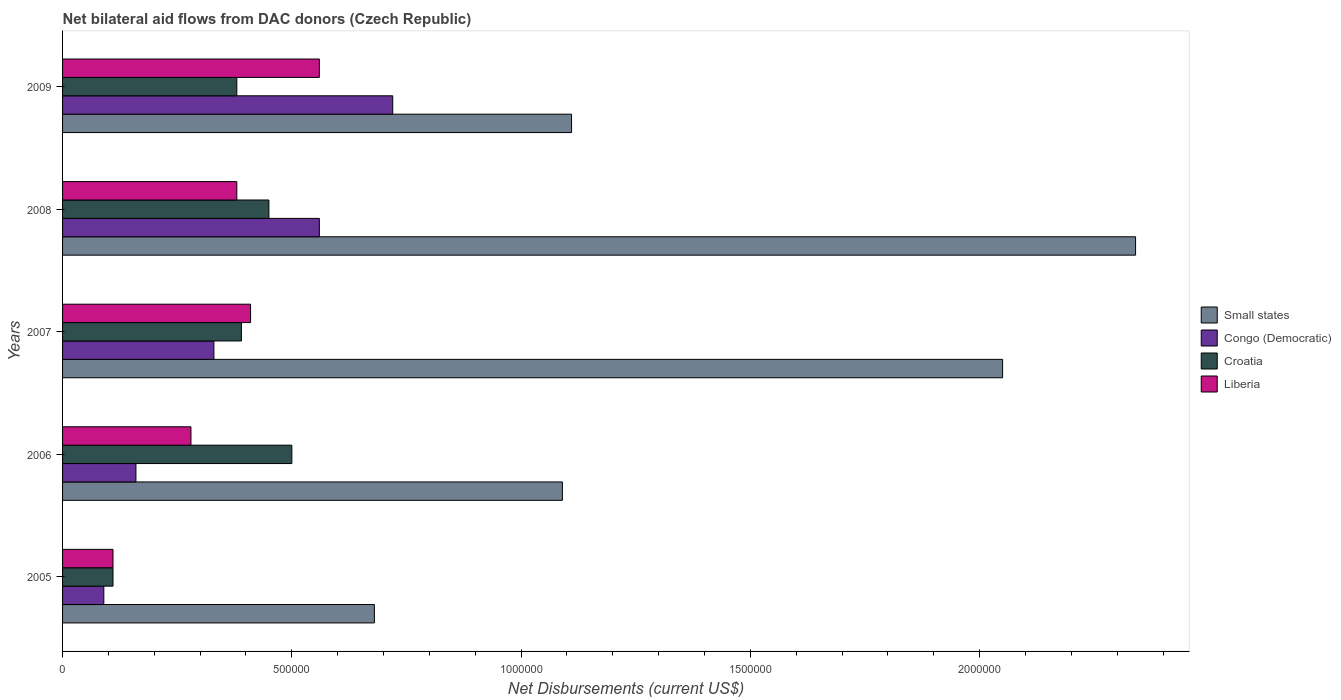How many different coloured bars are there?
Make the answer very short. 4. Are the number of bars per tick equal to the number of legend labels?
Your answer should be very brief. Yes. In how many cases, is the number of bars for a given year not equal to the number of legend labels?
Give a very brief answer. 0. What is the net bilateral aid flows in Small states in 2009?
Your response must be concise. 1.11e+06. Across all years, what is the maximum net bilateral aid flows in Small states?
Keep it short and to the point. 2.34e+06. In which year was the net bilateral aid flows in Small states maximum?
Your answer should be compact. 2008. In which year was the net bilateral aid flows in Congo (Democratic) minimum?
Provide a succinct answer. 2005. What is the total net bilateral aid flows in Croatia in the graph?
Offer a terse response. 1.83e+06. What is the difference between the net bilateral aid flows in Croatia in 2008 and that in 2009?
Make the answer very short. 7.00e+04. What is the difference between the net bilateral aid flows in Croatia in 2009 and the net bilateral aid flows in Congo (Democratic) in 2007?
Your response must be concise. 5.00e+04. What is the average net bilateral aid flows in Congo (Democratic) per year?
Provide a succinct answer. 3.72e+05. In the year 2009, what is the difference between the net bilateral aid flows in Small states and net bilateral aid flows in Congo (Democratic)?
Make the answer very short. 3.90e+05. What is the ratio of the net bilateral aid flows in Small states in 2005 to that in 2006?
Keep it short and to the point. 0.62. Is the net bilateral aid flows in Congo (Democratic) in 2005 less than that in 2006?
Provide a succinct answer. Yes. Is the difference between the net bilateral aid flows in Small states in 2008 and 2009 greater than the difference between the net bilateral aid flows in Congo (Democratic) in 2008 and 2009?
Your answer should be very brief. Yes. What is the difference between the highest and the second highest net bilateral aid flows in Liberia?
Make the answer very short. 1.50e+05. What is the difference between the highest and the lowest net bilateral aid flows in Liberia?
Your response must be concise. 4.50e+05. In how many years, is the net bilateral aid flows in Croatia greater than the average net bilateral aid flows in Croatia taken over all years?
Give a very brief answer. 4. What does the 4th bar from the top in 2005 represents?
Provide a short and direct response. Small states. What does the 3rd bar from the bottom in 2009 represents?
Provide a succinct answer. Croatia. Is it the case that in every year, the sum of the net bilateral aid flows in Liberia and net bilateral aid flows in Congo (Democratic) is greater than the net bilateral aid flows in Croatia?
Keep it short and to the point. No. What is the difference between two consecutive major ticks on the X-axis?
Keep it short and to the point. 5.00e+05. Are the values on the major ticks of X-axis written in scientific E-notation?
Make the answer very short. No. Does the graph contain any zero values?
Your response must be concise. No. How many legend labels are there?
Ensure brevity in your answer.  4. How are the legend labels stacked?
Provide a short and direct response. Vertical. What is the title of the graph?
Give a very brief answer. Net bilateral aid flows from DAC donors (Czech Republic). Does "Swaziland" appear as one of the legend labels in the graph?
Your response must be concise. No. What is the label or title of the X-axis?
Give a very brief answer. Net Disbursements (current US$). What is the label or title of the Y-axis?
Make the answer very short. Years. What is the Net Disbursements (current US$) in Small states in 2005?
Provide a short and direct response. 6.80e+05. What is the Net Disbursements (current US$) in Congo (Democratic) in 2005?
Keep it short and to the point. 9.00e+04. What is the Net Disbursements (current US$) of Croatia in 2005?
Your response must be concise. 1.10e+05. What is the Net Disbursements (current US$) in Liberia in 2005?
Your response must be concise. 1.10e+05. What is the Net Disbursements (current US$) of Small states in 2006?
Make the answer very short. 1.09e+06. What is the Net Disbursements (current US$) in Liberia in 2006?
Offer a terse response. 2.80e+05. What is the Net Disbursements (current US$) of Small states in 2007?
Offer a very short reply. 2.05e+06. What is the Net Disbursements (current US$) of Small states in 2008?
Offer a very short reply. 2.34e+06. What is the Net Disbursements (current US$) in Congo (Democratic) in 2008?
Offer a terse response. 5.60e+05. What is the Net Disbursements (current US$) of Small states in 2009?
Make the answer very short. 1.11e+06. What is the Net Disbursements (current US$) in Congo (Democratic) in 2009?
Provide a succinct answer. 7.20e+05. What is the Net Disbursements (current US$) of Liberia in 2009?
Provide a succinct answer. 5.60e+05. Across all years, what is the maximum Net Disbursements (current US$) in Small states?
Ensure brevity in your answer.  2.34e+06. Across all years, what is the maximum Net Disbursements (current US$) in Congo (Democratic)?
Make the answer very short. 7.20e+05. Across all years, what is the maximum Net Disbursements (current US$) in Croatia?
Make the answer very short. 5.00e+05. Across all years, what is the maximum Net Disbursements (current US$) of Liberia?
Keep it short and to the point. 5.60e+05. Across all years, what is the minimum Net Disbursements (current US$) in Small states?
Give a very brief answer. 6.80e+05. Across all years, what is the minimum Net Disbursements (current US$) of Liberia?
Your answer should be compact. 1.10e+05. What is the total Net Disbursements (current US$) of Small states in the graph?
Offer a terse response. 7.27e+06. What is the total Net Disbursements (current US$) of Congo (Democratic) in the graph?
Your answer should be very brief. 1.86e+06. What is the total Net Disbursements (current US$) in Croatia in the graph?
Offer a terse response. 1.83e+06. What is the total Net Disbursements (current US$) of Liberia in the graph?
Offer a very short reply. 1.74e+06. What is the difference between the Net Disbursements (current US$) in Small states in 2005 and that in 2006?
Ensure brevity in your answer.  -4.10e+05. What is the difference between the Net Disbursements (current US$) in Croatia in 2005 and that in 2006?
Provide a short and direct response. -3.90e+05. What is the difference between the Net Disbursements (current US$) in Small states in 2005 and that in 2007?
Provide a succinct answer. -1.37e+06. What is the difference between the Net Disbursements (current US$) of Croatia in 2005 and that in 2007?
Provide a succinct answer. -2.80e+05. What is the difference between the Net Disbursements (current US$) of Liberia in 2005 and that in 2007?
Offer a very short reply. -3.00e+05. What is the difference between the Net Disbursements (current US$) of Small states in 2005 and that in 2008?
Your answer should be compact. -1.66e+06. What is the difference between the Net Disbursements (current US$) of Congo (Democratic) in 2005 and that in 2008?
Offer a very short reply. -4.70e+05. What is the difference between the Net Disbursements (current US$) of Croatia in 2005 and that in 2008?
Keep it short and to the point. -3.40e+05. What is the difference between the Net Disbursements (current US$) in Liberia in 2005 and that in 2008?
Your response must be concise. -2.70e+05. What is the difference between the Net Disbursements (current US$) of Small states in 2005 and that in 2009?
Your answer should be very brief. -4.30e+05. What is the difference between the Net Disbursements (current US$) in Congo (Democratic) in 2005 and that in 2009?
Ensure brevity in your answer.  -6.30e+05. What is the difference between the Net Disbursements (current US$) of Croatia in 2005 and that in 2009?
Offer a terse response. -2.70e+05. What is the difference between the Net Disbursements (current US$) of Liberia in 2005 and that in 2009?
Your answer should be very brief. -4.50e+05. What is the difference between the Net Disbursements (current US$) of Small states in 2006 and that in 2007?
Offer a terse response. -9.60e+05. What is the difference between the Net Disbursements (current US$) in Congo (Democratic) in 2006 and that in 2007?
Give a very brief answer. -1.70e+05. What is the difference between the Net Disbursements (current US$) of Croatia in 2006 and that in 2007?
Provide a succinct answer. 1.10e+05. What is the difference between the Net Disbursements (current US$) of Liberia in 2006 and that in 2007?
Make the answer very short. -1.30e+05. What is the difference between the Net Disbursements (current US$) of Small states in 2006 and that in 2008?
Offer a very short reply. -1.25e+06. What is the difference between the Net Disbursements (current US$) in Congo (Democratic) in 2006 and that in 2008?
Your answer should be very brief. -4.00e+05. What is the difference between the Net Disbursements (current US$) of Liberia in 2006 and that in 2008?
Make the answer very short. -1.00e+05. What is the difference between the Net Disbursements (current US$) in Small states in 2006 and that in 2009?
Offer a terse response. -2.00e+04. What is the difference between the Net Disbursements (current US$) in Congo (Democratic) in 2006 and that in 2009?
Your answer should be very brief. -5.60e+05. What is the difference between the Net Disbursements (current US$) in Liberia in 2006 and that in 2009?
Your answer should be very brief. -2.80e+05. What is the difference between the Net Disbursements (current US$) of Small states in 2007 and that in 2008?
Ensure brevity in your answer.  -2.90e+05. What is the difference between the Net Disbursements (current US$) in Congo (Democratic) in 2007 and that in 2008?
Your answer should be very brief. -2.30e+05. What is the difference between the Net Disbursements (current US$) in Croatia in 2007 and that in 2008?
Your answer should be very brief. -6.00e+04. What is the difference between the Net Disbursements (current US$) in Liberia in 2007 and that in 2008?
Provide a short and direct response. 3.00e+04. What is the difference between the Net Disbursements (current US$) of Small states in 2007 and that in 2009?
Provide a short and direct response. 9.40e+05. What is the difference between the Net Disbursements (current US$) of Congo (Democratic) in 2007 and that in 2009?
Make the answer very short. -3.90e+05. What is the difference between the Net Disbursements (current US$) in Liberia in 2007 and that in 2009?
Keep it short and to the point. -1.50e+05. What is the difference between the Net Disbursements (current US$) in Small states in 2008 and that in 2009?
Ensure brevity in your answer.  1.23e+06. What is the difference between the Net Disbursements (current US$) of Croatia in 2008 and that in 2009?
Provide a short and direct response. 7.00e+04. What is the difference between the Net Disbursements (current US$) of Liberia in 2008 and that in 2009?
Offer a terse response. -1.80e+05. What is the difference between the Net Disbursements (current US$) of Small states in 2005 and the Net Disbursements (current US$) of Congo (Democratic) in 2006?
Make the answer very short. 5.20e+05. What is the difference between the Net Disbursements (current US$) of Small states in 2005 and the Net Disbursements (current US$) of Croatia in 2006?
Make the answer very short. 1.80e+05. What is the difference between the Net Disbursements (current US$) in Small states in 2005 and the Net Disbursements (current US$) in Liberia in 2006?
Offer a terse response. 4.00e+05. What is the difference between the Net Disbursements (current US$) of Congo (Democratic) in 2005 and the Net Disbursements (current US$) of Croatia in 2006?
Provide a succinct answer. -4.10e+05. What is the difference between the Net Disbursements (current US$) in Congo (Democratic) in 2005 and the Net Disbursements (current US$) in Liberia in 2006?
Offer a very short reply. -1.90e+05. What is the difference between the Net Disbursements (current US$) of Small states in 2005 and the Net Disbursements (current US$) of Congo (Democratic) in 2007?
Give a very brief answer. 3.50e+05. What is the difference between the Net Disbursements (current US$) of Congo (Democratic) in 2005 and the Net Disbursements (current US$) of Croatia in 2007?
Give a very brief answer. -3.00e+05. What is the difference between the Net Disbursements (current US$) of Congo (Democratic) in 2005 and the Net Disbursements (current US$) of Liberia in 2007?
Ensure brevity in your answer.  -3.20e+05. What is the difference between the Net Disbursements (current US$) in Croatia in 2005 and the Net Disbursements (current US$) in Liberia in 2007?
Provide a succinct answer. -3.00e+05. What is the difference between the Net Disbursements (current US$) in Small states in 2005 and the Net Disbursements (current US$) in Congo (Democratic) in 2008?
Offer a terse response. 1.20e+05. What is the difference between the Net Disbursements (current US$) of Small states in 2005 and the Net Disbursements (current US$) of Liberia in 2008?
Ensure brevity in your answer.  3.00e+05. What is the difference between the Net Disbursements (current US$) in Congo (Democratic) in 2005 and the Net Disbursements (current US$) in Croatia in 2008?
Ensure brevity in your answer.  -3.60e+05. What is the difference between the Net Disbursements (current US$) of Croatia in 2005 and the Net Disbursements (current US$) of Liberia in 2008?
Give a very brief answer. -2.70e+05. What is the difference between the Net Disbursements (current US$) in Small states in 2005 and the Net Disbursements (current US$) in Congo (Democratic) in 2009?
Ensure brevity in your answer.  -4.00e+04. What is the difference between the Net Disbursements (current US$) of Small states in 2005 and the Net Disbursements (current US$) of Croatia in 2009?
Provide a succinct answer. 3.00e+05. What is the difference between the Net Disbursements (current US$) in Congo (Democratic) in 2005 and the Net Disbursements (current US$) in Croatia in 2009?
Your answer should be very brief. -2.90e+05. What is the difference between the Net Disbursements (current US$) of Congo (Democratic) in 2005 and the Net Disbursements (current US$) of Liberia in 2009?
Your answer should be very brief. -4.70e+05. What is the difference between the Net Disbursements (current US$) of Croatia in 2005 and the Net Disbursements (current US$) of Liberia in 2009?
Make the answer very short. -4.50e+05. What is the difference between the Net Disbursements (current US$) of Small states in 2006 and the Net Disbursements (current US$) of Congo (Democratic) in 2007?
Provide a succinct answer. 7.60e+05. What is the difference between the Net Disbursements (current US$) of Small states in 2006 and the Net Disbursements (current US$) of Croatia in 2007?
Offer a very short reply. 7.00e+05. What is the difference between the Net Disbursements (current US$) in Small states in 2006 and the Net Disbursements (current US$) in Liberia in 2007?
Give a very brief answer. 6.80e+05. What is the difference between the Net Disbursements (current US$) in Croatia in 2006 and the Net Disbursements (current US$) in Liberia in 2007?
Give a very brief answer. 9.00e+04. What is the difference between the Net Disbursements (current US$) in Small states in 2006 and the Net Disbursements (current US$) in Congo (Democratic) in 2008?
Offer a terse response. 5.30e+05. What is the difference between the Net Disbursements (current US$) in Small states in 2006 and the Net Disbursements (current US$) in Croatia in 2008?
Provide a short and direct response. 6.40e+05. What is the difference between the Net Disbursements (current US$) in Small states in 2006 and the Net Disbursements (current US$) in Liberia in 2008?
Make the answer very short. 7.10e+05. What is the difference between the Net Disbursements (current US$) of Congo (Democratic) in 2006 and the Net Disbursements (current US$) of Croatia in 2008?
Ensure brevity in your answer.  -2.90e+05. What is the difference between the Net Disbursements (current US$) in Congo (Democratic) in 2006 and the Net Disbursements (current US$) in Liberia in 2008?
Make the answer very short. -2.20e+05. What is the difference between the Net Disbursements (current US$) of Croatia in 2006 and the Net Disbursements (current US$) of Liberia in 2008?
Keep it short and to the point. 1.20e+05. What is the difference between the Net Disbursements (current US$) of Small states in 2006 and the Net Disbursements (current US$) of Croatia in 2009?
Give a very brief answer. 7.10e+05. What is the difference between the Net Disbursements (current US$) in Small states in 2006 and the Net Disbursements (current US$) in Liberia in 2009?
Keep it short and to the point. 5.30e+05. What is the difference between the Net Disbursements (current US$) in Congo (Democratic) in 2006 and the Net Disbursements (current US$) in Croatia in 2009?
Your answer should be compact. -2.20e+05. What is the difference between the Net Disbursements (current US$) in Congo (Democratic) in 2006 and the Net Disbursements (current US$) in Liberia in 2009?
Provide a succinct answer. -4.00e+05. What is the difference between the Net Disbursements (current US$) in Croatia in 2006 and the Net Disbursements (current US$) in Liberia in 2009?
Provide a short and direct response. -6.00e+04. What is the difference between the Net Disbursements (current US$) in Small states in 2007 and the Net Disbursements (current US$) in Congo (Democratic) in 2008?
Keep it short and to the point. 1.49e+06. What is the difference between the Net Disbursements (current US$) of Small states in 2007 and the Net Disbursements (current US$) of Croatia in 2008?
Give a very brief answer. 1.60e+06. What is the difference between the Net Disbursements (current US$) in Small states in 2007 and the Net Disbursements (current US$) in Liberia in 2008?
Your answer should be compact. 1.67e+06. What is the difference between the Net Disbursements (current US$) in Congo (Democratic) in 2007 and the Net Disbursements (current US$) in Croatia in 2008?
Keep it short and to the point. -1.20e+05. What is the difference between the Net Disbursements (current US$) of Congo (Democratic) in 2007 and the Net Disbursements (current US$) of Liberia in 2008?
Your response must be concise. -5.00e+04. What is the difference between the Net Disbursements (current US$) of Croatia in 2007 and the Net Disbursements (current US$) of Liberia in 2008?
Your response must be concise. 10000. What is the difference between the Net Disbursements (current US$) in Small states in 2007 and the Net Disbursements (current US$) in Congo (Democratic) in 2009?
Offer a terse response. 1.33e+06. What is the difference between the Net Disbursements (current US$) in Small states in 2007 and the Net Disbursements (current US$) in Croatia in 2009?
Offer a very short reply. 1.67e+06. What is the difference between the Net Disbursements (current US$) of Small states in 2007 and the Net Disbursements (current US$) of Liberia in 2009?
Your response must be concise. 1.49e+06. What is the difference between the Net Disbursements (current US$) in Congo (Democratic) in 2007 and the Net Disbursements (current US$) in Croatia in 2009?
Offer a terse response. -5.00e+04. What is the difference between the Net Disbursements (current US$) in Congo (Democratic) in 2007 and the Net Disbursements (current US$) in Liberia in 2009?
Your answer should be compact. -2.30e+05. What is the difference between the Net Disbursements (current US$) in Small states in 2008 and the Net Disbursements (current US$) in Congo (Democratic) in 2009?
Your response must be concise. 1.62e+06. What is the difference between the Net Disbursements (current US$) in Small states in 2008 and the Net Disbursements (current US$) in Croatia in 2009?
Provide a short and direct response. 1.96e+06. What is the difference between the Net Disbursements (current US$) of Small states in 2008 and the Net Disbursements (current US$) of Liberia in 2009?
Provide a succinct answer. 1.78e+06. What is the difference between the Net Disbursements (current US$) of Croatia in 2008 and the Net Disbursements (current US$) of Liberia in 2009?
Make the answer very short. -1.10e+05. What is the average Net Disbursements (current US$) in Small states per year?
Ensure brevity in your answer.  1.45e+06. What is the average Net Disbursements (current US$) in Congo (Democratic) per year?
Provide a short and direct response. 3.72e+05. What is the average Net Disbursements (current US$) of Croatia per year?
Provide a succinct answer. 3.66e+05. What is the average Net Disbursements (current US$) in Liberia per year?
Your answer should be compact. 3.48e+05. In the year 2005, what is the difference between the Net Disbursements (current US$) of Small states and Net Disbursements (current US$) of Congo (Democratic)?
Make the answer very short. 5.90e+05. In the year 2005, what is the difference between the Net Disbursements (current US$) of Small states and Net Disbursements (current US$) of Croatia?
Provide a succinct answer. 5.70e+05. In the year 2005, what is the difference between the Net Disbursements (current US$) of Small states and Net Disbursements (current US$) of Liberia?
Provide a succinct answer. 5.70e+05. In the year 2005, what is the difference between the Net Disbursements (current US$) of Congo (Democratic) and Net Disbursements (current US$) of Croatia?
Keep it short and to the point. -2.00e+04. In the year 2005, what is the difference between the Net Disbursements (current US$) of Congo (Democratic) and Net Disbursements (current US$) of Liberia?
Offer a very short reply. -2.00e+04. In the year 2005, what is the difference between the Net Disbursements (current US$) of Croatia and Net Disbursements (current US$) of Liberia?
Your answer should be very brief. 0. In the year 2006, what is the difference between the Net Disbursements (current US$) in Small states and Net Disbursements (current US$) in Congo (Democratic)?
Offer a very short reply. 9.30e+05. In the year 2006, what is the difference between the Net Disbursements (current US$) of Small states and Net Disbursements (current US$) of Croatia?
Ensure brevity in your answer.  5.90e+05. In the year 2006, what is the difference between the Net Disbursements (current US$) in Small states and Net Disbursements (current US$) in Liberia?
Your response must be concise. 8.10e+05. In the year 2006, what is the difference between the Net Disbursements (current US$) of Congo (Democratic) and Net Disbursements (current US$) of Croatia?
Provide a succinct answer. -3.40e+05. In the year 2006, what is the difference between the Net Disbursements (current US$) of Croatia and Net Disbursements (current US$) of Liberia?
Make the answer very short. 2.20e+05. In the year 2007, what is the difference between the Net Disbursements (current US$) in Small states and Net Disbursements (current US$) in Congo (Democratic)?
Offer a terse response. 1.72e+06. In the year 2007, what is the difference between the Net Disbursements (current US$) in Small states and Net Disbursements (current US$) in Croatia?
Ensure brevity in your answer.  1.66e+06. In the year 2007, what is the difference between the Net Disbursements (current US$) of Small states and Net Disbursements (current US$) of Liberia?
Ensure brevity in your answer.  1.64e+06. In the year 2007, what is the difference between the Net Disbursements (current US$) of Congo (Democratic) and Net Disbursements (current US$) of Croatia?
Give a very brief answer. -6.00e+04. In the year 2007, what is the difference between the Net Disbursements (current US$) of Croatia and Net Disbursements (current US$) of Liberia?
Offer a terse response. -2.00e+04. In the year 2008, what is the difference between the Net Disbursements (current US$) of Small states and Net Disbursements (current US$) of Congo (Democratic)?
Offer a terse response. 1.78e+06. In the year 2008, what is the difference between the Net Disbursements (current US$) of Small states and Net Disbursements (current US$) of Croatia?
Provide a short and direct response. 1.89e+06. In the year 2008, what is the difference between the Net Disbursements (current US$) in Small states and Net Disbursements (current US$) in Liberia?
Provide a short and direct response. 1.96e+06. In the year 2009, what is the difference between the Net Disbursements (current US$) in Small states and Net Disbursements (current US$) in Croatia?
Your response must be concise. 7.30e+05. In the year 2009, what is the difference between the Net Disbursements (current US$) of Congo (Democratic) and Net Disbursements (current US$) of Croatia?
Offer a terse response. 3.40e+05. In the year 2009, what is the difference between the Net Disbursements (current US$) in Congo (Democratic) and Net Disbursements (current US$) in Liberia?
Offer a terse response. 1.60e+05. What is the ratio of the Net Disbursements (current US$) of Small states in 2005 to that in 2006?
Provide a short and direct response. 0.62. What is the ratio of the Net Disbursements (current US$) in Congo (Democratic) in 2005 to that in 2006?
Give a very brief answer. 0.56. What is the ratio of the Net Disbursements (current US$) of Croatia in 2005 to that in 2006?
Provide a succinct answer. 0.22. What is the ratio of the Net Disbursements (current US$) of Liberia in 2005 to that in 2006?
Give a very brief answer. 0.39. What is the ratio of the Net Disbursements (current US$) in Small states in 2005 to that in 2007?
Your answer should be compact. 0.33. What is the ratio of the Net Disbursements (current US$) of Congo (Democratic) in 2005 to that in 2007?
Ensure brevity in your answer.  0.27. What is the ratio of the Net Disbursements (current US$) of Croatia in 2005 to that in 2007?
Make the answer very short. 0.28. What is the ratio of the Net Disbursements (current US$) in Liberia in 2005 to that in 2007?
Give a very brief answer. 0.27. What is the ratio of the Net Disbursements (current US$) of Small states in 2005 to that in 2008?
Your answer should be very brief. 0.29. What is the ratio of the Net Disbursements (current US$) of Congo (Democratic) in 2005 to that in 2008?
Give a very brief answer. 0.16. What is the ratio of the Net Disbursements (current US$) of Croatia in 2005 to that in 2008?
Make the answer very short. 0.24. What is the ratio of the Net Disbursements (current US$) of Liberia in 2005 to that in 2008?
Provide a short and direct response. 0.29. What is the ratio of the Net Disbursements (current US$) in Small states in 2005 to that in 2009?
Provide a succinct answer. 0.61. What is the ratio of the Net Disbursements (current US$) in Croatia in 2005 to that in 2009?
Give a very brief answer. 0.29. What is the ratio of the Net Disbursements (current US$) of Liberia in 2005 to that in 2009?
Provide a short and direct response. 0.2. What is the ratio of the Net Disbursements (current US$) in Small states in 2006 to that in 2007?
Make the answer very short. 0.53. What is the ratio of the Net Disbursements (current US$) of Congo (Democratic) in 2006 to that in 2007?
Keep it short and to the point. 0.48. What is the ratio of the Net Disbursements (current US$) of Croatia in 2006 to that in 2007?
Make the answer very short. 1.28. What is the ratio of the Net Disbursements (current US$) in Liberia in 2006 to that in 2007?
Ensure brevity in your answer.  0.68. What is the ratio of the Net Disbursements (current US$) in Small states in 2006 to that in 2008?
Your answer should be compact. 0.47. What is the ratio of the Net Disbursements (current US$) of Congo (Democratic) in 2006 to that in 2008?
Offer a terse response. 0.29. What is the ratio of the Net Disbursements (current US$) of Liberia in 2006 to that in 2008?
Give a very brief answer. 0.74. What is the ratio of the Net Disbursements (current US$) in Congo (Democratic) in 2006 to that in 2009?
Offer a very short reply. 0.22. What is the ratio of the Net Disbursements (current US$) in Croatia in 2006 to that in 2009?
Ensure brevity in your answer.  1.32. What is the ratio of the Net Disbursements (current US$) of Small states in 2007 to that in 2008?
Your answer should be compact. 0.88. What is the ratio of the Net Disbursements (current US$) in Congo (Democratic) in 2007 to that in 2008?
Provide a succinct answer. 0.59. What is the ratio of the Net Disbursements (current US$) in Croatia in 2007 to that in 2008?
Provide a short and direct response. 0.87. What is the ratio of the Net Disbursements (current US$) of Liberia in 2007 to that in 2008?
Offer a terse response. 1.08. What is the ratio of the Net Disbursements (current US$) of Small states in 2007 to that in 2009?
Give a very brief answer. 1.85. What is the ratio of the Net Disbursements (current US$) of Congo (Democratic) in 2007 to that in 2009?
Give a very brief answer. 0.46. What is the ratio of the Net Disbursements (current US$) in Croatia in 2007 to that in 2009?
Your response must be concise. 1.03. What is the ratio of the Net Disbursements (current US$) of Liberia in 2007 to that in 2009?
Provide a succinct answer. 0.73. What is the ratio of the Net Disbursements (current US$) in Small states in 2008 to that in 2009?
Keep it short and to the point. 2.11. What is the ratio of the Net Disbursements (current US$) in Croatia in 2008 to that in 2009?
Offer a very short reply. 1.18. What is the ratio of the Net Disbursements (current US$) in Liberia in 2008 to that in 2009?
Make the answer very short. 0.68. What is the difference between the highest and the second highest Net Disbursements (current US$) in Small states?
Keep it short and to the point. 2.90e+05. What is the difference between the highest and the second highest Net Disbursements (current US$) in Congo (Democratic)?
Keep it short and to the point. 1.60e+05. What is the difference between the highest and the second highest Net Disbursements (current US$) of Liberia?
Offer a very short reply. 1.50e+05. What is the difference between the highest and the lowest Net Disbursements (current US$) in Small states?
Give a very brief answer. 1.66e+06. What is the difference between the highest and the lowest Net Disbursements (current US$) in Congo (Democratic)?
Provide a succinct answer. 6.30e+05. What is the difference between the highest and the lowest Net Disbursements (current US$) in Liberia?
Make the answer very short. 4.50e+05. 